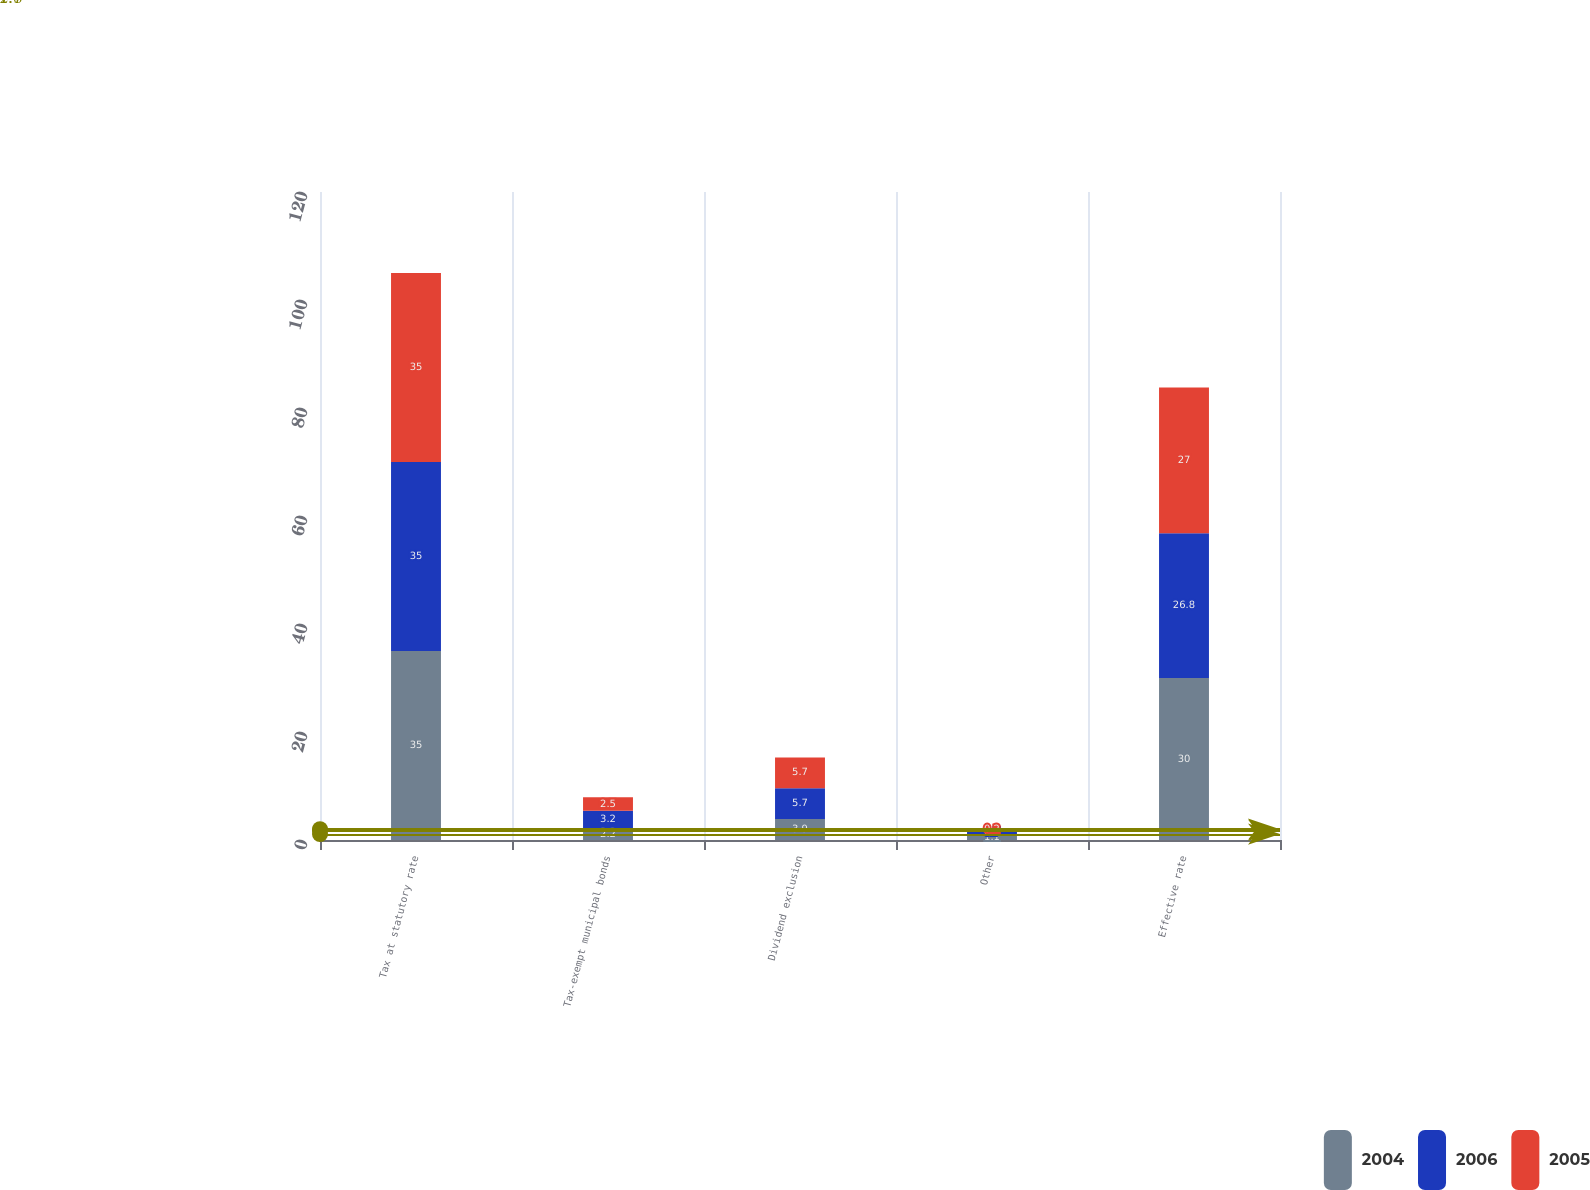<chart> <loc_0><loc_0><loc_500><loc_500><stacked_bar_chart><ecel><fcel>Tax at statutory rate<fcel>Tax-exempt municipal bonds<fcel>Dividend exclusion<fcel>Other<fcel>Effective rate<nl><fcel>2004<fcel>35<fcel>2.2<fcel>3.9<fcel>1.1<fcel>30<nl><fcel>2006<fcel>35<fcel>3.2<fcel>5.7<fcel>0.7<fcel>26.8<nl><fcel>2005<fcel>35<fcel>2.5<fcel>5.7<fcel>0.2<fcel>27<nl></chart> 